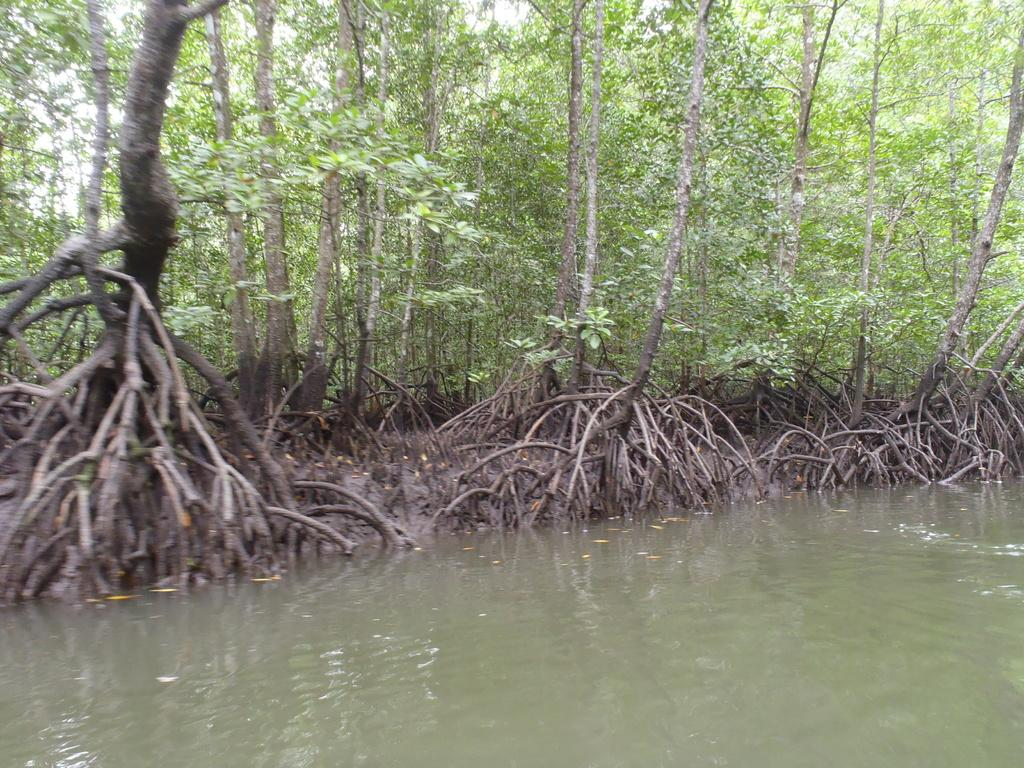What type of vegetation is present in the image? There are green trees in the image. What natural element can be seen alongside the trees? There is water visible in the image. What type of religion is practiced by the goldfish in the image? There are no goldfish present in the image, so it is not possible to determine what religion they might practice. 